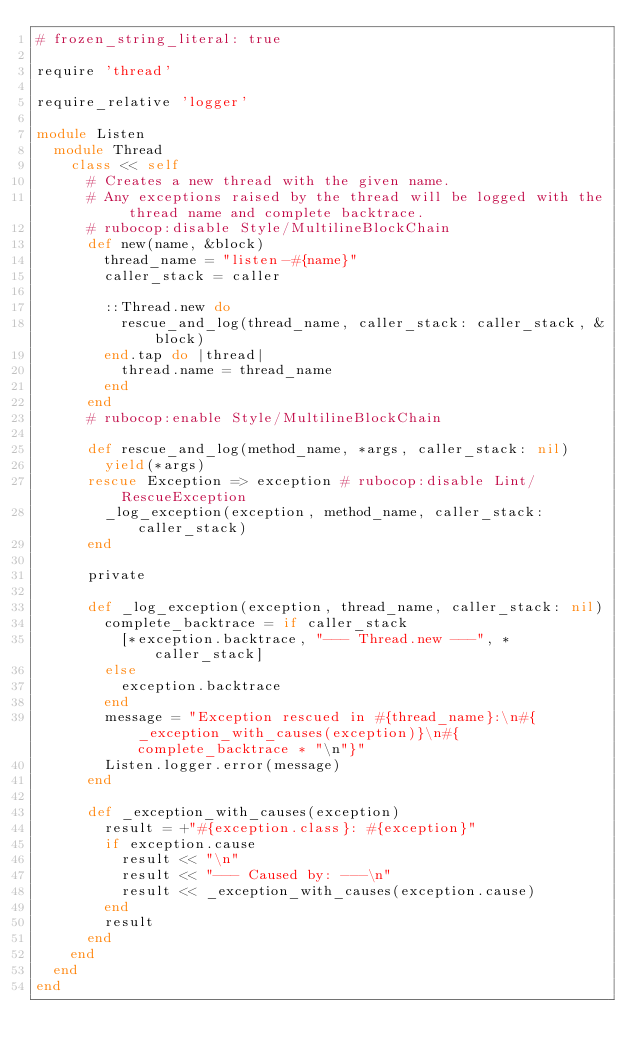<code> <loc_0><loc_0><loc_500><loc_500><_Ruby_># frozen_string_literal: true

require 'thread'

require_relative 'logger'

module Listen
  module Thread
    class << self
      # Creates a new thread with the given name.
      # Any exceptions raised by the thread will be logged with the thread name and complete backtrace.
      # rubocop:disable Style/MultilineBlockChain
      def new(name, &block)
        thread_name = "listen-#{name}"
        caller_stack = caller

        ::Thread.new do
          rescue_and_log(thread_name, caller_stack: caller_stack, &block)
        end.tap do |thread|
          thread.name = thread_name
        end
      end
      # rubocop:enable Style/MultilineBlockChain

      def rescue_and_log(method_name, *args, caller_stack: nil)
        yield(*args)
      rescue Exception => exception # rubocop:disable Lint/RescueException
        _log_exception(exception, method_name, caller_stack: caller_stack)
      end

      private

      def _log_exception(exception, thread_name, caller_stack: nil)
        complete_backtrace = if caller_stack
          [*exception.backtrace, "--- Thread.new ---", *caller_stack]
        else
          exception.backtrace
        end
        message = "Exception rescued in #{thread_name}:\n#{_exception_with_causes(exception)}\n#{complete_backtrace * "\n"}"
        Listen.logger.error(message)
      end

      def _exception_with_causes(exception)
        result = +"#{exception.class}: #{exception}"
        if exception.cause
          result << "\n"
          result << "--- Caused by: ---\n"
          result << _exception_with_causes(exception.cause)
        end
        result
      end
    end
  end
end
</code> 